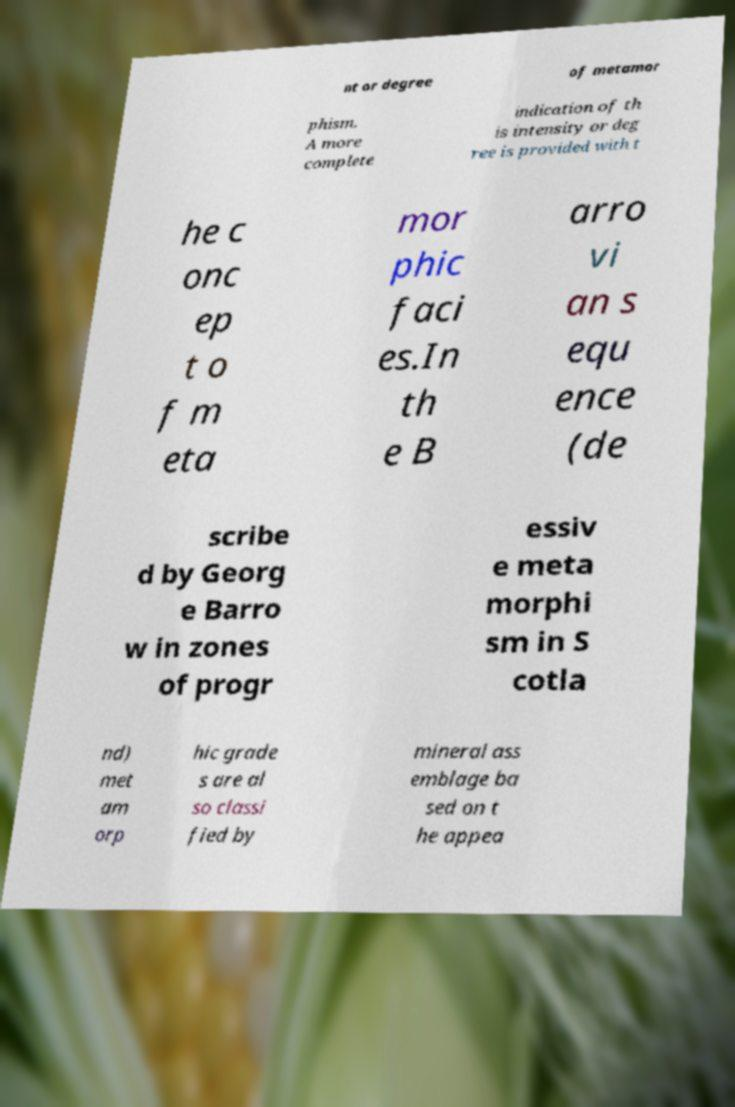Can you read and provide the text displayed in the image?This photo seems to have some interesting text. Can you extract and type it out for me? nt or degree of metamor phism. A more complete indication of th is intensity or deg ree is provided with t he c onc ep t o f m eta mor phic faci es.In th e B arro vi an s equ ence (de scribe d by Georg e Barro w in zones of progr essiv e meta morphi sm in S cotla nd) met am orp hic grade s are al so classi fied by mineral ass emblage ba sed on t he appea 